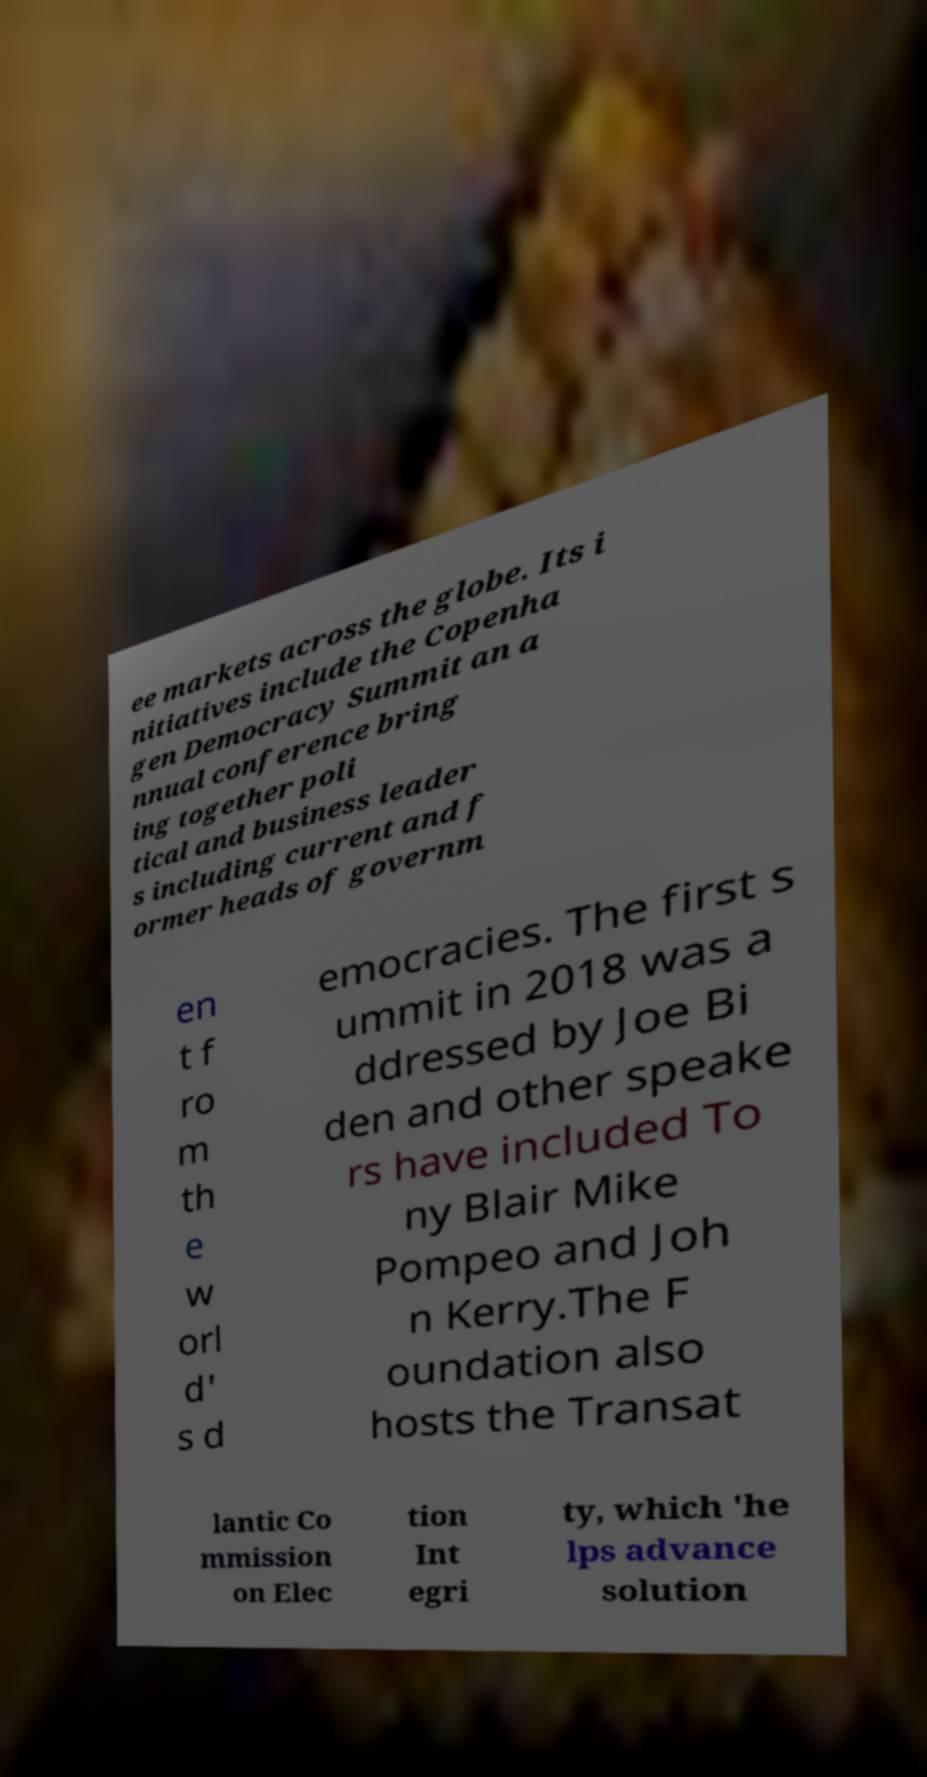Please read and relay the text visible in this image. What does it say? ee markets across the globe. Its i nitiatives include the Copenha gen Democracy Summit an a nnual conference bring ing together poli tical and business leader s including current and f ormer heads of governm en t f ro m th e w orl d' s d emocracies. The first s ummit in 2018 was a ddressed by Joe Bi den and other speake rs have included To ny Blair Mike Pompeo and Joh n Kerry.The F oundation also hosts the Transat lantic Co mmission on Elec tion Int egri ty, which 'he lps advance solution 